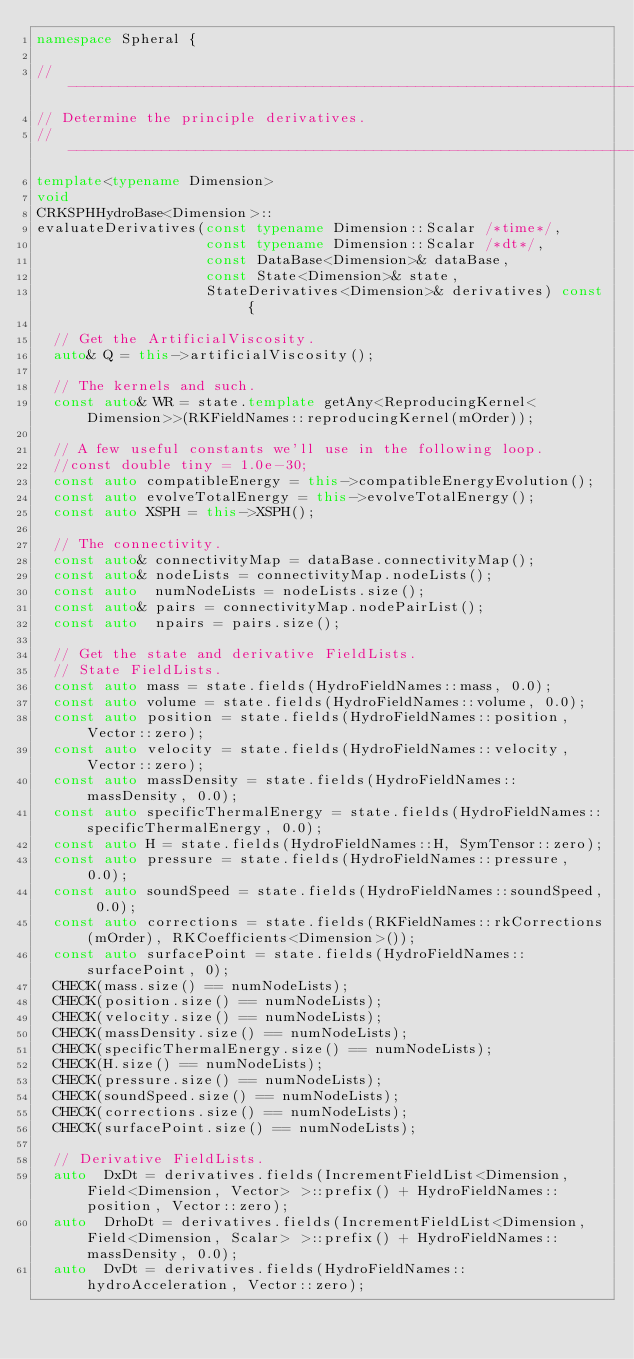Convert code to text. <code><loc_0><loc_0><loc_500><loc_500><_C++_>namespace Spheral {

//------------------------------------------------------------------------------
// Determine the principle derivatives.
//------------------------------------------------------------------------------
template<typename Dimension>
void
CRKSPHHydroBase<Dimension>::
evaluateDerivatives(const typename Dimension::Scalar /*time*/,
                    const typename Dimension::Scalar /*dt*/,
                    const DataBase<Dimension>& dataBase,
                    const State<Dimension>& state,
                    StateDerivatives<Dimension>& derivatives) const {

  // Get the ArtificialViscosity.
  auto& Q = this->artificialViscosity();

  // The kernels and such.
  const auto& WR = state.template getAny<ReproducingKernel<Dimension>>(RKFieldNames::reproducingKernel(mOrder));

  // A few useful constants we'll use in the following loop.
  //const double tiny = 1.0e-30;
  const auto compatibleEnergy = this->compatibleEnergyEvolution();
  const auto evolveTotalEnergy = this->evolveTotalEnergy();
  const auto XSPH = this->XSPH();

  // The connectivity.
  const auto& connectivityMap = dataBase.connectivityMap();
  const auto& nodeLists = connectivityMap.nodeLists();
  const auto  numNodeLists = nodeLists.size();
  const auto& pairs = connectivityMap.nodePairList();
  const auto  npairs = pairs.size();

  // Get the state and derivative FieldLists.
  // State FieldLists.
  const auto mass = state.fields(HydroFieldNames::mass, 0.0);
  const auto volume = state.fields(HydroFieldNames::volume, 0.0);
  const auto position = state.fields(HydroFieldNames::position, Vector::zero);
  const auto velocity = state.fields(HydroFieldNames::velocity, Vector::zero);
  const auto massDensity = state.fields(HydroFieldNames::massDensity, 0.0);
  const auto specificThermalEnergy = state.fields(HydroFieldNames::specificThermalEnergy, 0.0);
  const auto H = state.fields(HydroFieldNames::H, SymTensor::zero);
  const auto pressure = state.fields(HydroFieldNames::pressure, 0.0);
  const auto soundSpeed = state.fields(HydroFieldNames::soundSpeed, 0.0);
  const auto corrections = state.fields(RKFieldNames::rkCorrections(mOrder), RKCoefficients<Dimension>());
  const auto surfacePoint = state.fields(HydroFieldNames::surfacePoint, 0);
  CHECK(mass.size() == numNodeLists);
  CHECK(position.size() == numNodeLists);
  CHECK(velocity.size() == numNodeLists);
  CHECK(massDensity.size() == numNodeLists);
  CHECK(specificThermalEnergy.size() == numNodeLists);
  CHECK(H.size() == numNodeLists);
  CHECK(pressure.size() == numNodeLists);
  CHECK(soundSpeed.size() == numNodeLists);
  CHECK(corrections.size() == numNodeLists);
  CHECK(surfacePoint.size() == numNodeLists);

  // Derivative FieldLists.
  auto  DxDt = derivatives.fields(IncrementFieldList<Dimension, Field<Dimension, Vector> >::prefix() + HydroFieldNames::position, Vector::zero);
  auto  DrhoDt = derivatives.fields(IncrementFieldList<Dimension, Field<Dimension, Scalar> >::prefix() + HydroFieldNames::massDensity, 0.0);
  auto  DvDt = derivatives.fields(HydroFieldNames::hydroAcceleration, Vector::zero);</code> 